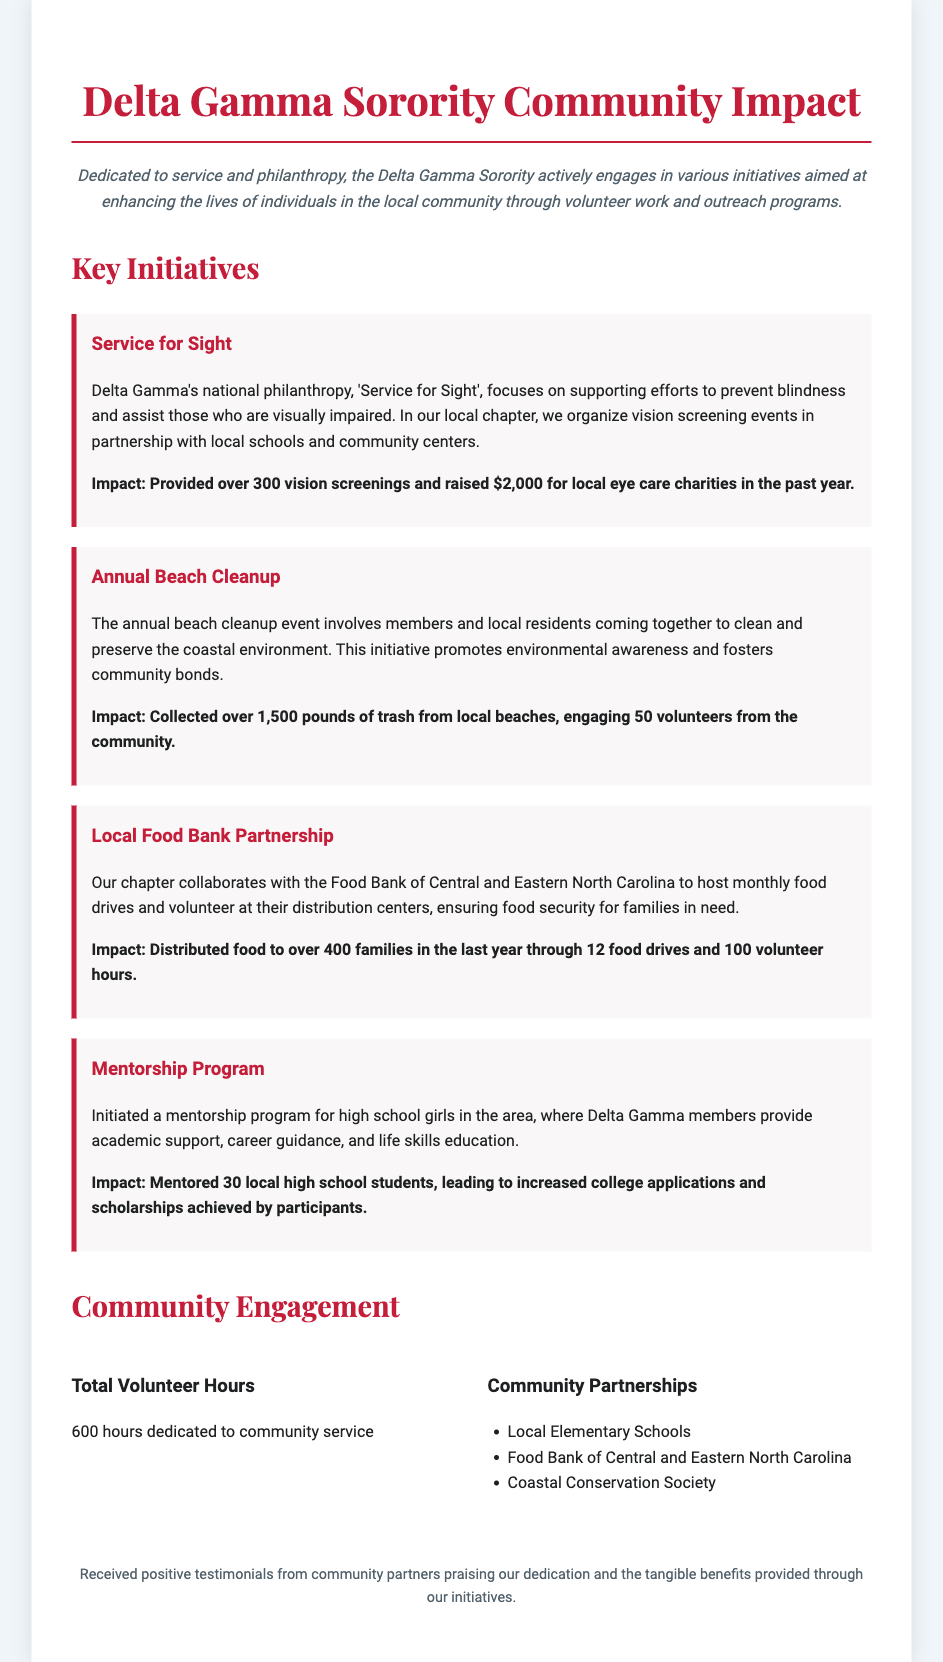What is the main focus of Delta Gamma's national philanthropy? The main focus of Delta Gamma's national philanthropy is to support efforts to prevent blindness and assist those who are visually impaired.
Answer: Prevent blindness How much money was raised for local eye care charities? The document states that $2,000 was raised for local eye care charities in the past year.
Answer: $2,000 How many pounds of trash were collected during the annual beach cleanup? The beach cleanup collected over 1,500 pounds of trash from local beaches.
Answer: 1,500 pounds How many families received food through the local food bank partnership? The initiative distributed food to over 400 families in the last year.
Answer: 400 families What is the total number of volunteer hours dedicated to community service? The total volunteer hours dedicated to community service according to the document is 600 hours.
Answer: 600 hours Which local community organization partners with Delta Gamma for monthly food drives? The organization that partners with Delta Gamma for monthly food drives is the Food Bank of Central and Eastern North Carolina.
Answer: Food Bank of Central and Eastern North Carolina What type of program was initiated for high school girls? The program initiated was a mentorship program.
Answer: Mentorship program How many local high school students were mentored in the program? The document mentions that 30 local high school students were mentored.
Answer: 30 students What is the color theme mentioned in Delta Gamma's branding according to the document? The document primarily mentions a color theme of red and white, seen in the title and impact highlights.
Answer: Red and white 